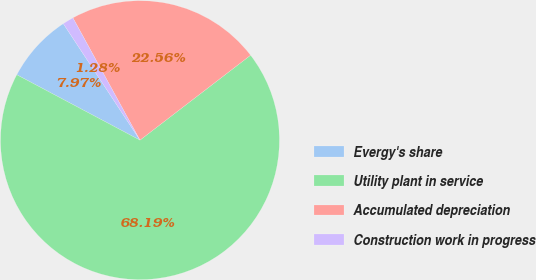<chart> <loc_0><loc_0><loc_500><loc_500><pie_chart><fcel>Evergy's share<fcel>Utility plant in service<fcel>Accumulated depreciation<fcel>Construction work in progress<nl><fcel>7.97%<fcel>68.19%<fcel>22.56%<fcel>1.28%<nl></chart> 